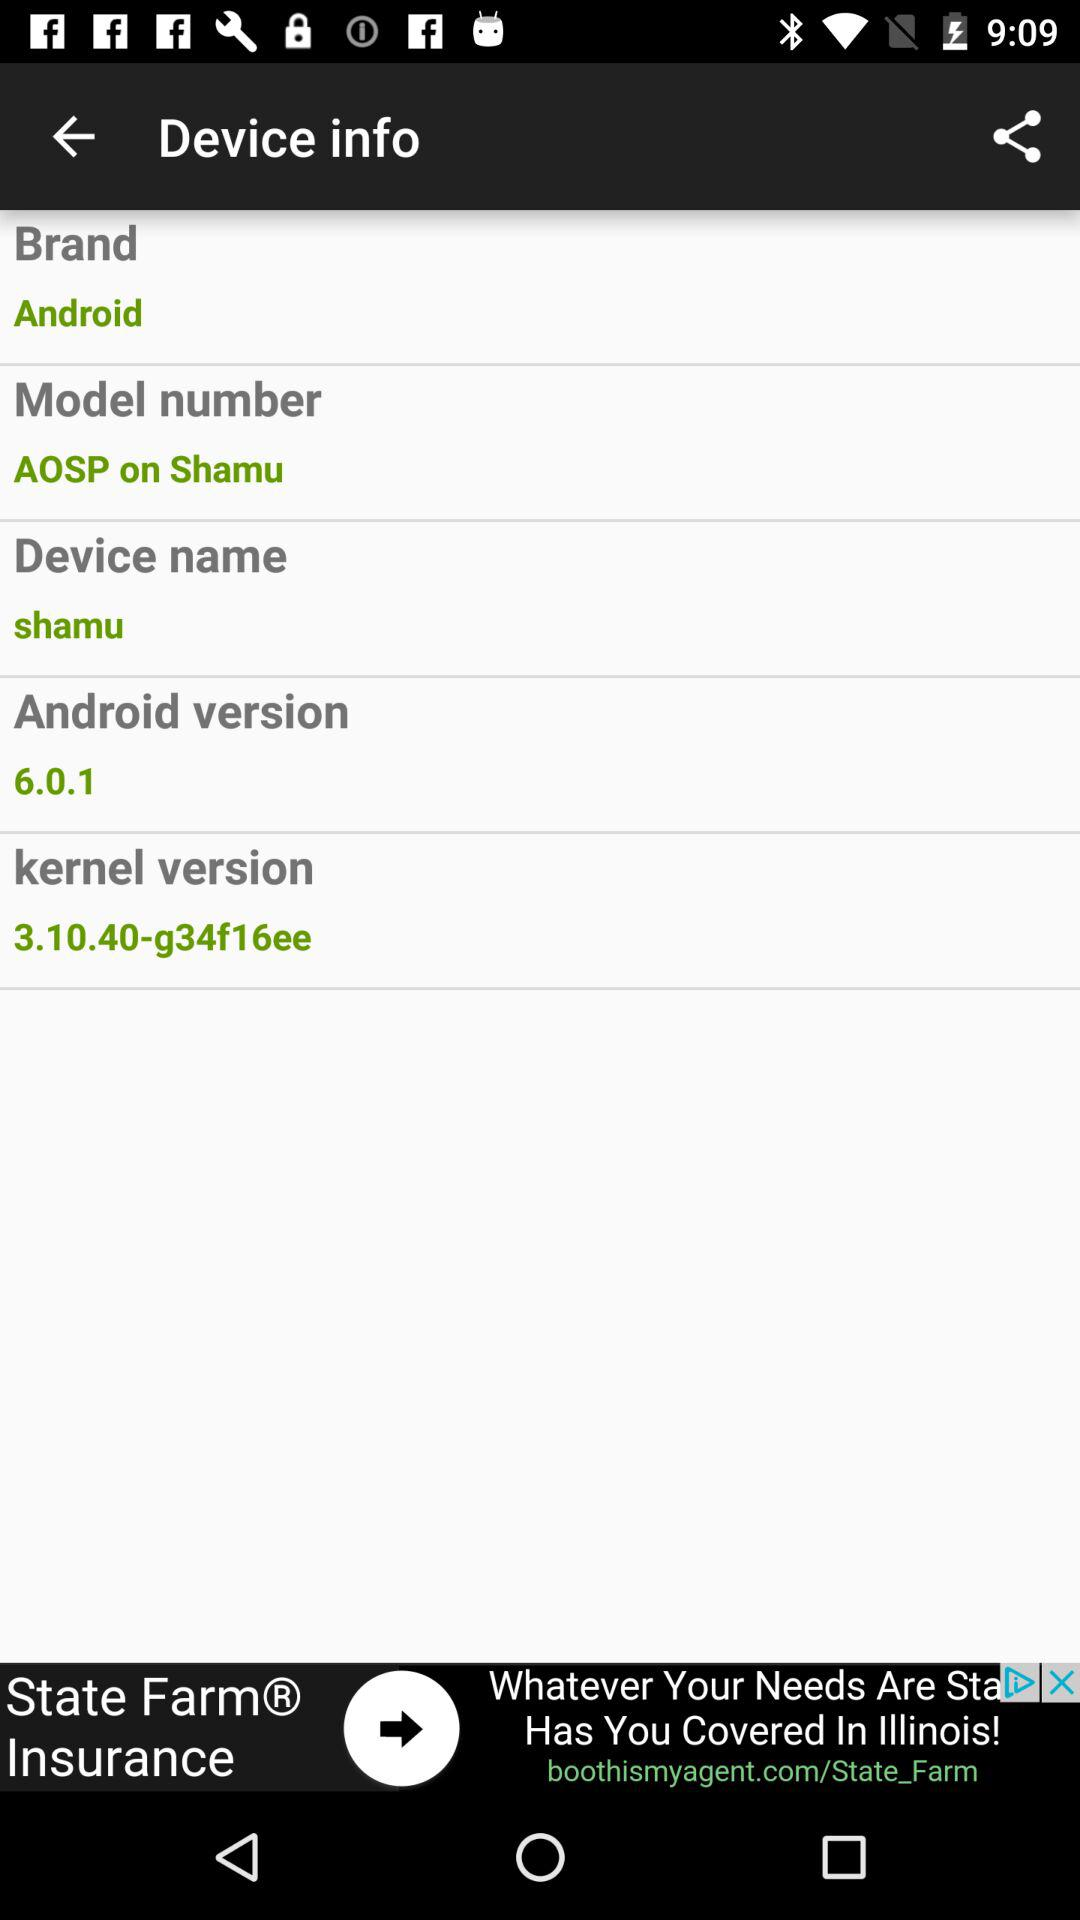What is the brand name? The brand name is "Android". 